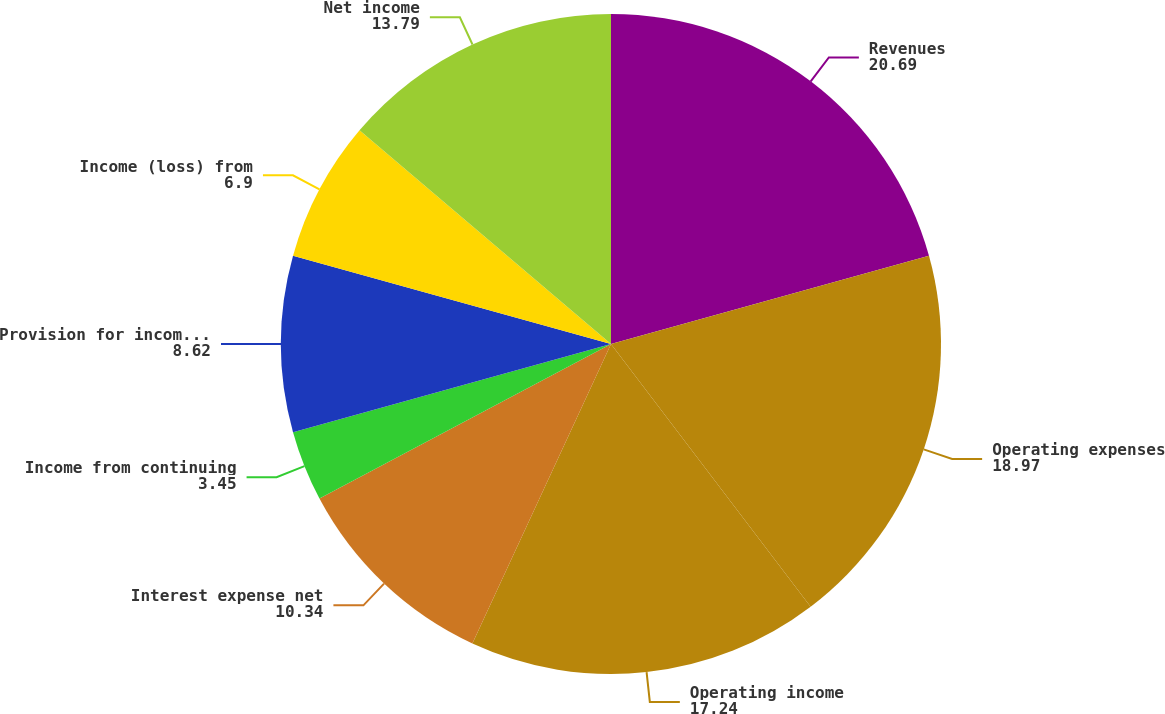Convert chart. <chart><loc_0><loc_0><loc_500><loc_500><pie_chart><fcel>Revenues<fcel>Operating expenses<fcel>Operating income<fcel>Interest expense net<fcel>Income from continuing<fcel>Provision for income taxes<fcel>Income (loss) from<fcel>Net income<nl><fcel>20.69%<fcel>18.97%<fcel>17.24%<fcel>10.34%<fcel>3.45%<fcel>8.62%<fcel>6.9%<fcel>13.79%<nl></chart> 